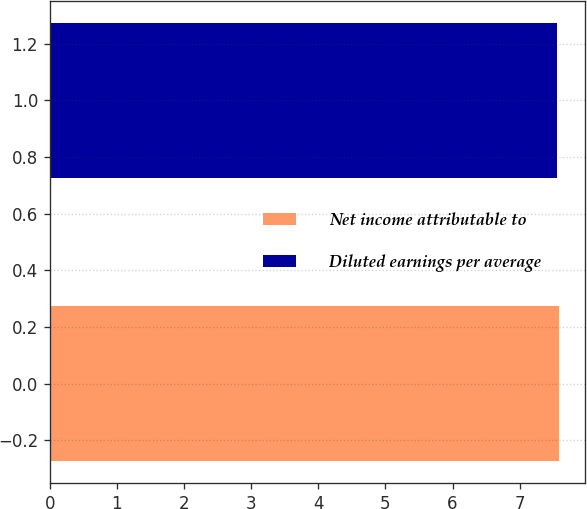Convert chart. <chart><loc_0><loc_0><loc_500><loc_500><bar_chart><fcel>Net income attributable to<fcel>Diluted earnings per average<nl><fcel>7.59<fcel>7.55<nl></chart> 